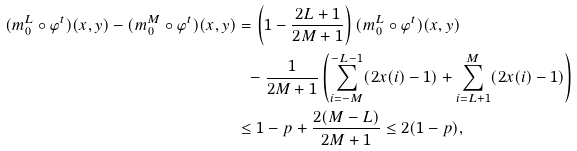<formula> <loc_0><loc_0><loc_500><loc_500>( m _ { 0 } ^ { L } \circ \varphi ^ { t } ) ( x , y ) - ( m _ { 0 } ^ { M } \circ \varphi ^ { t } ) ( x , y ) & = \left ( 1 - \frac { 2 L + 1 } { 2 M + 1 } \right ) ( m _ { 0 } ^ { L } \circ \varphi ^ { t } ) ( x , y ) \\ & \ \ - \frac { 1 } { 2 M + 1 } \left ( \sum _ { i = - M } ^ { - L - 1 } ( 2 x ( i ) - 1 ) + \sum _ { i = L + 1 } ^ { M } ( 2 x ( i ) - 1 ) \right ) \\ & \leq 1 - p + \frac { 2 ( M - L ) } { 2 M + 1 } \leq 2 ( 1 - p ) ,</formula> 